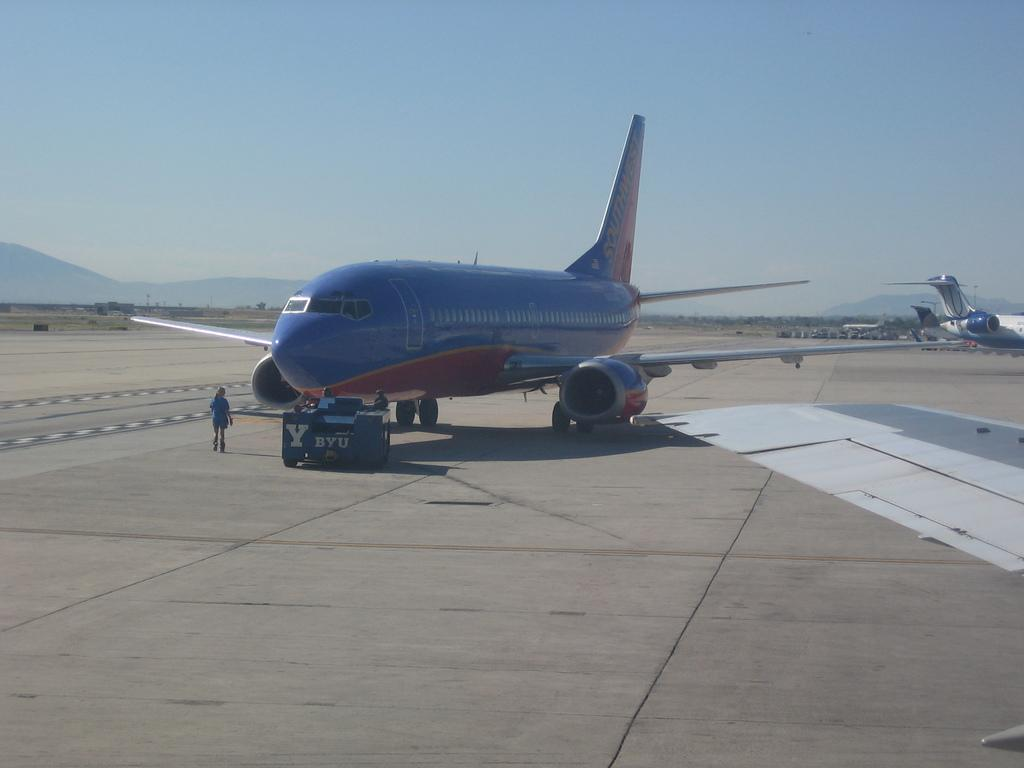Provide a one-sentence caption for the provided image. A blue airplane with southwest written on the tail. 